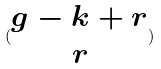<formula> <loc_0><loc_0><loc_500><loc_500>( \begin{matrix} g - k + r \\ r \end{matrix} )</formula> 